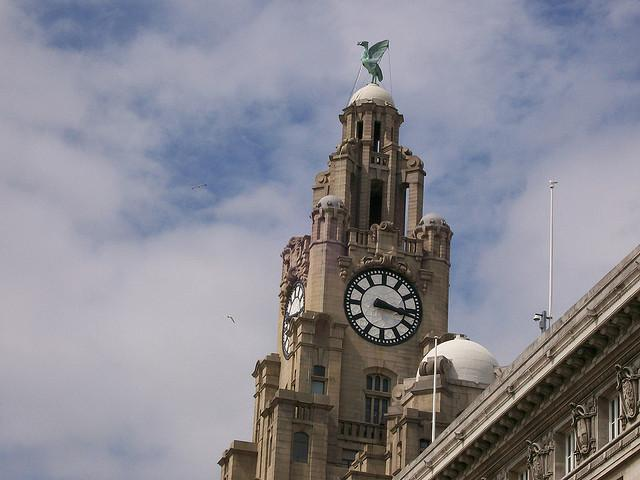Why are there ropes on the statue? Please explain your reasoning. stability. The ropes are attached to the statue for stability. 